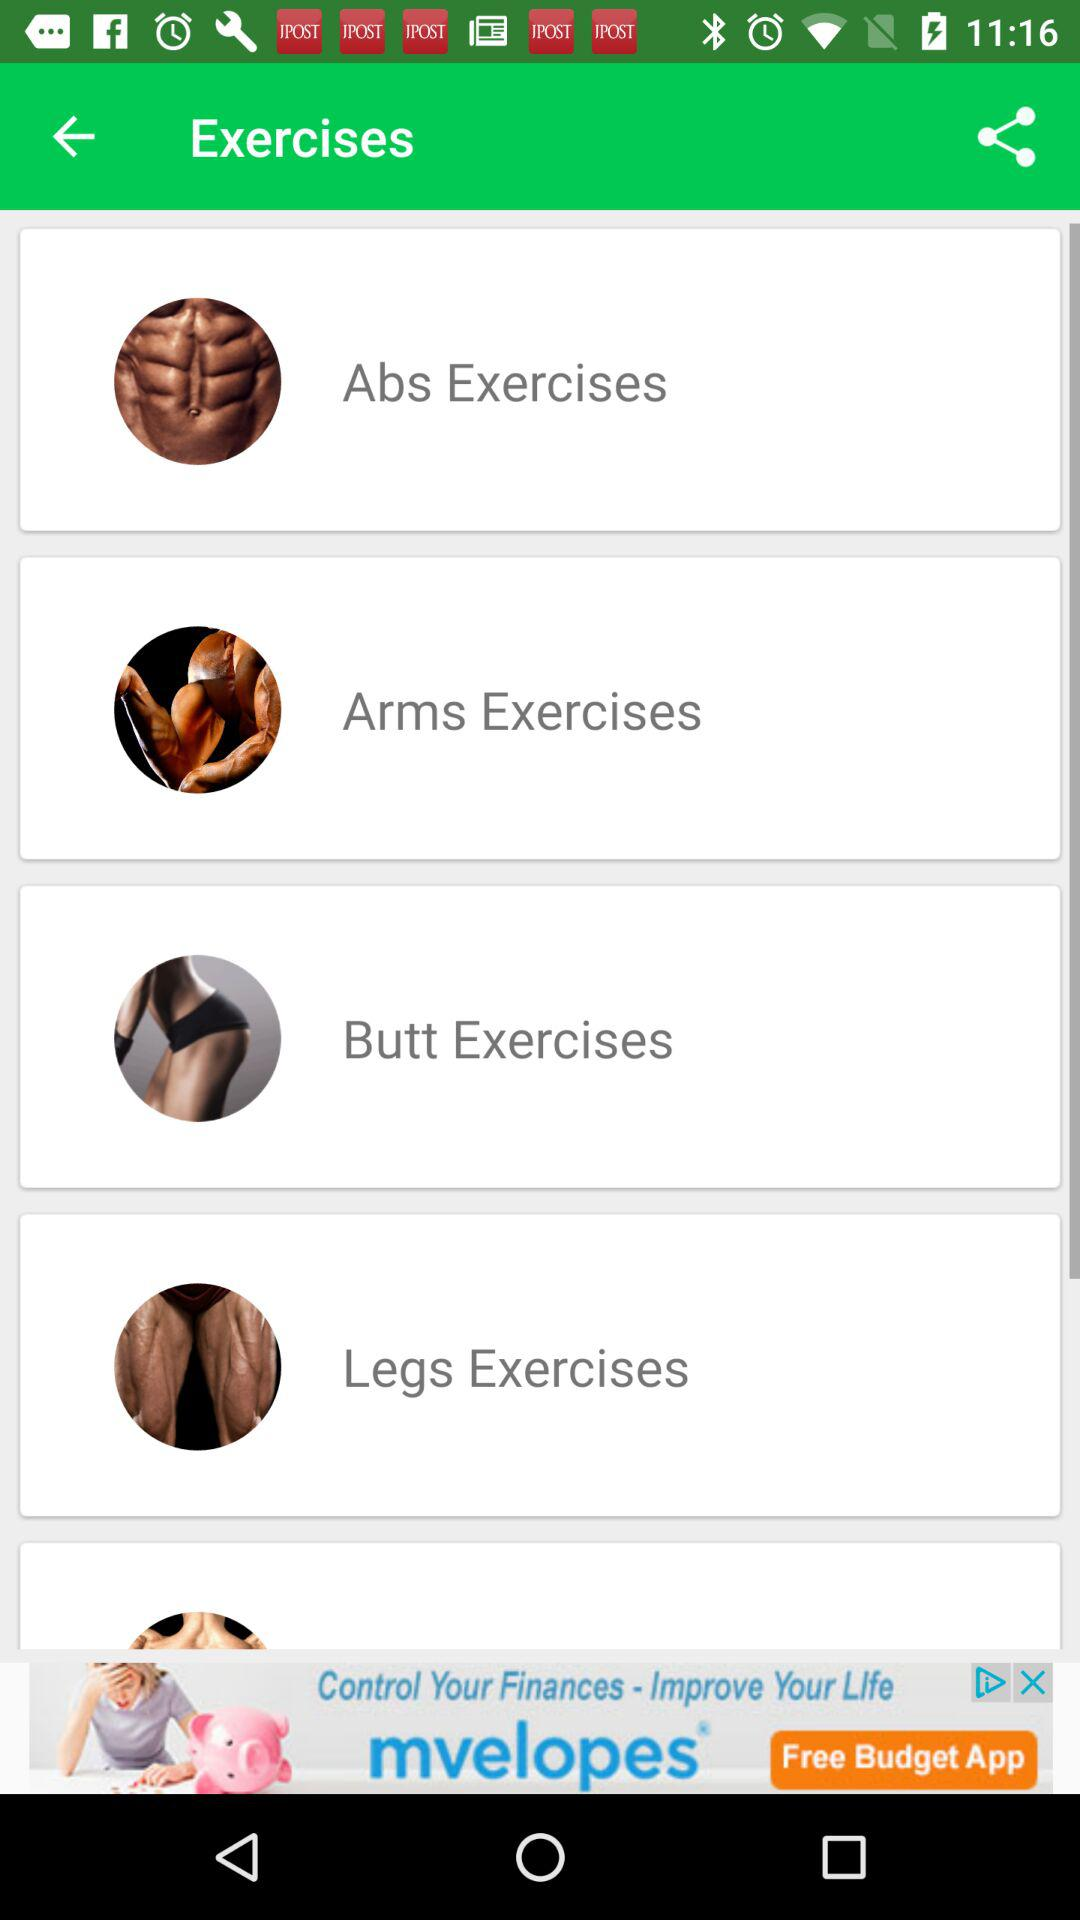Which type of exercise do we have on the screen? The types of exercises we have on the screen are "Abs Exercises", "Arms Exercises", "Butt Exercises" and "Legs Exercises". 